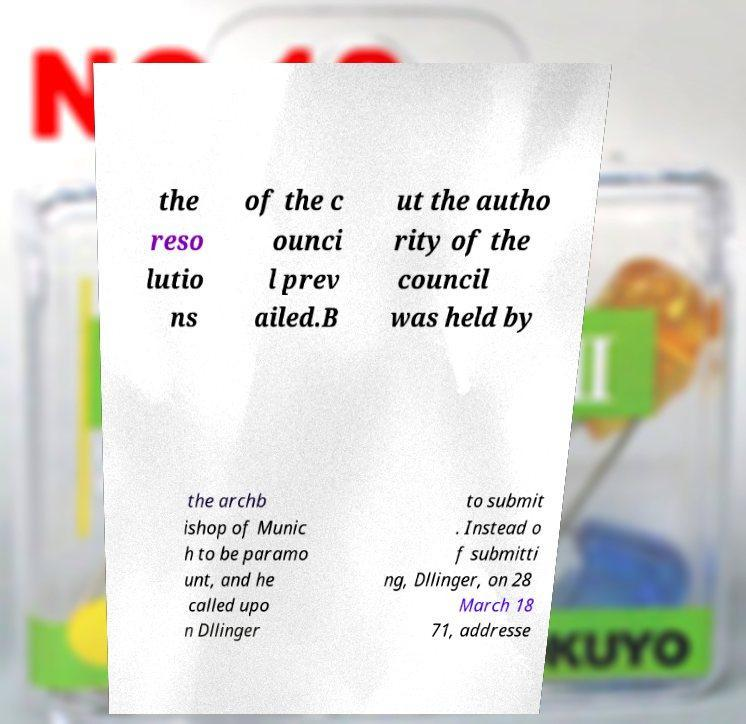I need the written content from this picture converted into text. Can you do that? the reso lutio ns of the c ounci l prev ailed.B ut the autho rity of the council was held by the archb ishop of Munic h to be paramo unt, and he called upo n Dllinger to submit . Instead o f submitti ng, Dllinger, on 28 March 18 71, addresse 